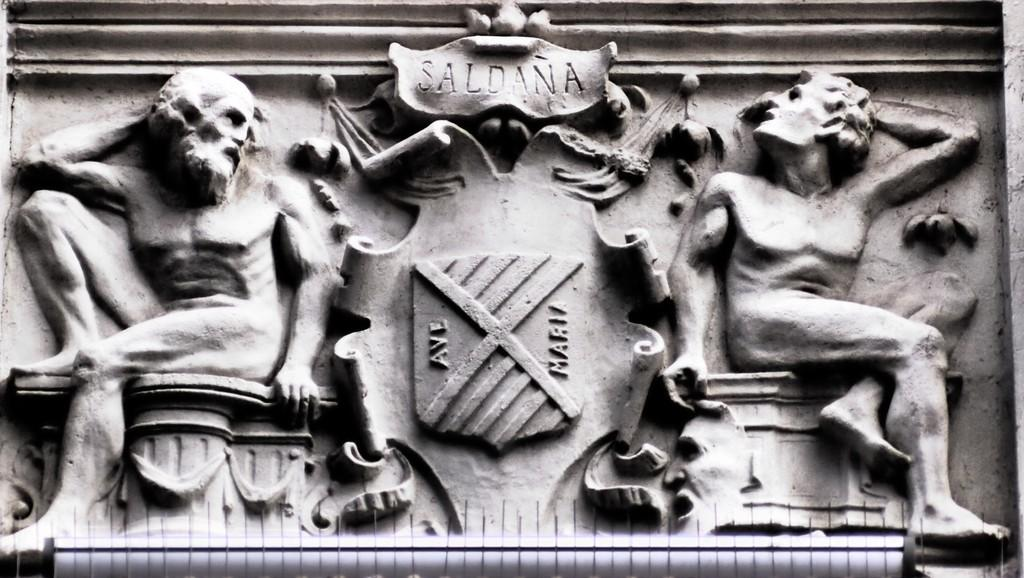<image>
Provide a brief description of the given image. a carved sign for Saldana has two people on it 